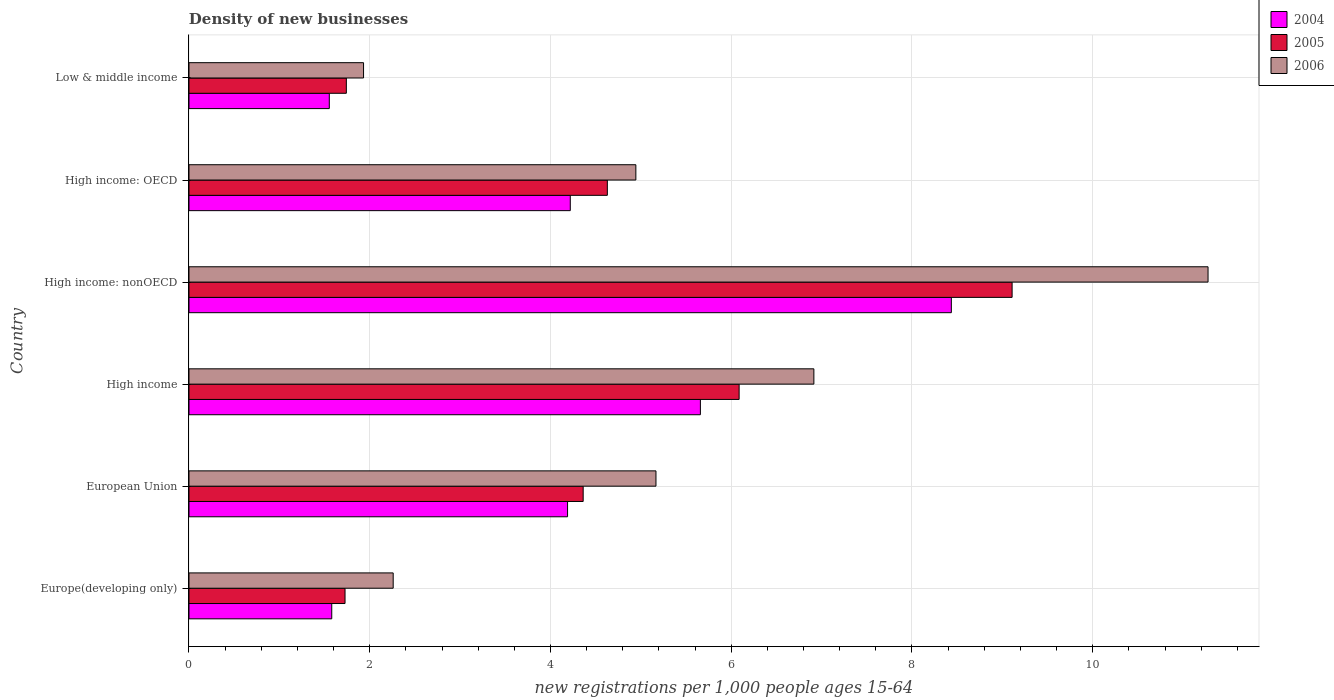How many groups of bars are there?
Keep it short and to the point. 6. Are the number of bars on each tick of the Y-axis equal?
Provide a short and direct response. Yes. How many bars are there on the 5th tick from the top?
Ensure brevity in your answer.  3. How many bars are there on the 6th tick from the bottom?
Offer a very short reply. 3. What is the label of the 5th group of bars from the top?
Your response must be concise. European Union. What is the number of new registrations in 2005 in Europe(developing only)?
Your answer should be very brief. 1.73. Across all countries, what is the maximum number of new registrations in 2006?
Give a very brief answer. 11.28. Across all countries, what is the minimum number of new registrations in 2006?
Give a very brief answer. 1.93. In which country was the number of new registrations in 2005 maximum?
Ensure brevity in your answer.  High income: nonOECD. In which country was the number of new registrations in 2004 minimum?
Provide a succinct answer. Low & middle income. What is the total number of new registrations in 2005 in the graph?
Provide a succinct answer. 27.65. What is the difference between the number of new registrations in 2005 in High income: OECD and that in High income: nonOECD?
Provide a succinct answer. -4.48. What is the difference between the number of new registrations in 2005 in Europe(developing only) and the number of new registrations in 2006 in Low & middle income?
Provide a succinct answer. -0.2. What is the average number of new registrations in 2006 per country?
Keep it short and to the point. 5.42. What is the difference between the number of new registrations in 2005 and number of new registrations in 2006 in European Union?
Offer a terse response. -0.81. In how many countries, is the number of new registrations in 2005 greater than 7.2 ?
Provide a short and direct response. 1. What is the ratio of the number of new registrations in 2005 in European Union to that in High income?
Offer a very short reply. 0.72. Is the number of new registrations in 2004 in High income: nonOECD less than that in Low & middle income?
Provide a succinct answer. No. What is the difference between the highest and the second highest number of new registrations in 2004?
Your answer should be compact. 2.78. What is the difference between the highest and the lowest number of new registrations in 2006?
Your answer should be compact. 9.34. In how many countries, is the number of new registrations in 2005 greater than the average number of new registrations in 2005 taken over all countries?
Offer a very short reply. 3. What does the 3rd bar from the top in European Union represents?
Provide a succinct answer. 2004. Is it the case that in every country, the sum of the number of new registrations in 2005 and number of new registrations in 2004 is greater than the number of new registrations in 2006?
Your response must be concise. Yes. Are all the bars in the graph horizontal?
Your response must be concise. Yes. How many countries are there in the graph?
Offer a very short reply. 6. What is the difference between two consecutive major ticks on the X-axis?
Your answer should be very brief. 2. Does the graph contain grids?
Make the answer very short. Yes. How many legend labels are there?
Ensure brevity in your answer.  3. What is the title of the graph?
Your answer should be compact. Density of new businesses. What is the label or title of the X-axis?
Provide a short and direct response. New registrations per 1,0 people ages 15-64. What is the new registrations per 1,000 people ages 15-64 in 2004 in Europe(developing only)?
Your response must be concise. 1.58. What is the new registrations per 1,000 people ages 15-64 in 2005 in Europe(developing only)?
Give a very brief answer. 1.73. What is the new registrations per 1,000 people ages 15-64 in 2006 in Europe(developing only)?
Make the answer very short. 2.26. What is the new registrations per 1,000 people ages 15-64 in 2004 in European Union?
Your response must be concise. 4.19. What is the new registrations per 1,000 people ages 15-64 in 2005 in European Union?
Ensure brevity in your answer.  4.36. What is the new registrations per 1,000 people ages 15-64 of 2006 in European Union?
Your answer should be very brief. 5.17. What is the new registrations per 1,000 people ages 15-64 of 2004 in High income?
Your response must be concise. 5.66. What is the new registrations per 1,000 people ages 15-64 of 2005 in High income?
Make the answer very short. 6.09. What is the new registrations per 1,000 people ages 15-64 in 2006 in High income?
Your answer should be very brief. 6.91. What is the new registrations per 1,000 people ages 15-64 in 2004 in High income: nonOECD?
Offer a terse response. 8.44. What is the new registrations per 1,000 people ages 15-64 of 2005 in High income: nonOECD?
Give a very brief answer. 9.11. What is the new registrations per 1,000 people ages 15-64 of 2006 in High income: nonOECD?
Offer a very short reply. 11.28. What is the new registrations per 1,000 people ages 15-64 of 2004 in High income: OECD?
Your answer should be very brief. 4.22. What is the new registrations per 1,000 people ages 15-64 of 2005 in High income: OECD?
Ensure brevity in your answer.  4.63. What is the new registrations per 1,000 people ages 15-64 in 2006 in High income: OECD?
Keep it short and to the point. 4.94. What is the new registrations per 1,000 people ages 15-64 in 2004 in Low & middle income?
Give a very brief answer. 1.55. What is the new registrations per 1,000 people ages 15-64 in 2005 in Low & middle income?
Ensure brevity in your answer.  1.74. What is the new registrations per 1,000 people ages 15-64 of 2006 in Low & middle income?
Offer a very short reply. 1.93. Across all countries, what is the maximum new registrations per 1,000 people ages 15-64 of 2004?
Provide a short and direct response. 8.44. Across all countries, what is the maximum new registrations per 1,000 people ages 15-64 of 2005?
Give a very brief answer. 9.11. Across all countries, what is the maximum new registrations per 1,000 people ages 15-64 in 2006?
Offer a terse response. 11.28. Across all countries, what is the minimum new registrations per 1,000 people ages 15-64 in 2004?
Ensure brevity in your answer.  1.55. Across all countries, what is the minimum new registrations per 1,000 people ages 15-64 of 2005?
Offer a terse response. 1.73. Across all countries, what is the minimum new registrations per 1,000 people ages 15-64 in 2006?
Your response must be concise. 1.93. What is the total new registrations per 1,000 people ages 15-64 in 2004 in the graph?
Keep it short and to the point. 25.63. What is the total new registrations per 1,000 people ages 15-64 in 2005 in the graph?
Ensure brevity in your answer.  27.65. What is the total new registrations per 1,000 people ages 15-64 in 2006 in the graph?
Provide a short and direct response. 32.49. What is the difference between the new registrations per 1,000 people ages 15-64 of 2004 in Europe(developing only) and that in European Union?
Make the answer very short. -2.61. What is the difference between the new registrations per 1,000 people ages 15-64 in 2005 in Europe(developing only) and that in European Union?
Keep it short and to the point. -2.64. What is the difference between the new registrations per 1,000 people ages 15-64 of 2006 in Europe(developing only) and that in European Union?
Your answer should be compact. -2.91. What is the difference between the new registrations per 1,000 people ages 15-64 of 2004 in Europe(developing only) and that in High income?
Provide a succinct answer. -4.08. What is the difference between the new registrations per 1,000 people ages 15-64 in 2005 in Europe(developing only) and that in High income?
Your response must be concise. -4.36. What is the difference between the new registrations per 1,000 people ages 15-64 in 2006 in Europe(developing only) and that in High income?
Provide a short and direct response. -4.66. What is the difference between the new registrations per 1,000 people ages 15-64 in 2004 in Europe(developing only) and that in High income: nonOECD?
Give a very brief answer. -6.86. What is the difference between the new registrations per 1,000 people ages 15-64 in 2005 in Europe(developing only) and that in High income: nonOECD?
Provide a succinct answer. -7.38. What is the difference between the new registrations per 1,000 people ages 15-64 of 2006 in Europe(developing only) and that in High income: nonOECD?
Your response must be concise. -9.02. What is the difference between the new registrations per 1,000 people ages 15-64 in 2004 in Europe(developing only) and that in High income: OECD?
Your answer should be compact. -2.64. What is the difference between the new registrations per 1,000 people ages 15-64 in 2005 in Europe(developing only) and that in High income: OECD?
Your response must be concise. -2.9. What is the difference between the new registrations per 1,000 people ages 15-64 in 2006 in Europe(developing only) and that in High income: OECD?
Your response must be concise. -2.69. What is the difference between the new registrations per 1,000 people ages 15-64 in 2004 in Europe(developing only) and that in Low & middle income?
Offer a very short reply. 0.03. What is the difference between the new registrations per 1,000 people ages 15-64 of 2005 in Europe(developing only) and that in Low & middle income?
Ensure brevity in your answer.  -0.01. What is the difference between the new registrations per 1,000 people ages 15-64 of 2006 in Europe(developing only) and that in Low & middle income?
Your answer should be very brief. 0.33. What is the difference between the new registrations per 1,000 people ages 15-64 of 2004 in European Union and that in High income?
Ensure brevity in your answer.  -1.47. What is the difference between the new registrations per 1,000 people ages 15-64 in 2005 in European Union and that in High income?
Your response must be concise. -1.73. What is the difference between the new registrations per 1,000 people ages 15-64 in 2006 in European Union and that in High income?
Keep it short and to the point. -1.75. What is the difference between the new registrations per 1,000 people ages 15-64 in 2004 in European Union and that in High income: nonOECD?
Offer a very short reply. -4.25. What is the difference between the new registrations per 1,000 people ages 15-64 in 2005 in European Union and that in High income: nonOECD?
Your response must be concise. -4.75. What is the difference between the new registrations per 1,000 people ages 15-64 of 2006 in European Union and that in High income: nonOECD?
Make the answer very short. -6.11. What is the difference between the new registrations per 1,000 people ages 15-64 in 2004 in European Union and that in High income: OECD?
Keep it short and to the point. -0.03. What is the difference between the new registrations per 1,000 people ages 15-64 of 2005 in European Union and that in High income: OECD?
Make the answer very short. -0.27. What is the difference between the new registrations per 1,000 people ages 15-64 of 2006 in European Union and that in High income: OECD?
Provide a short and direct response. 0.22. What is the difference between the new registrations per 1,000 people ages 15-64 of 2004 in European Union and that in Low & middle income?
Your answer should be very brief. 2.64. What is the difference between the new registrations per 1,000 people ages 15-64 in 2005 in European Union and that in Low & middle income?
Keep it short and to the point. 2.62. What is the difference between the new registrations per 1,000 people ages 15-64 in 2006 in European Union and that in Low & middle income?
Keep it short and to the point. 3.24. What is the difference between the new registrations per 1,000 people ages 15-64 of 2004 in High income and that in High income: nonOECD?
Your answer should be compact. -2.78. What is the difference between the new registrations per 1,000 people ages 15-64 of 2005 in High income and that in High income: nonOECD?
Provide a succinct answer. -3.02. What is the difference between the new registrations per 1,000 people ages 15-64 in 2006 in High income and that in High income: nonOECD?
Keep it short and to the point. -4.36. What is the difference between the new registrations per 1,000 people ages 15-64 in 2004 in High income and that in High income: OECD?
Provide a succinct answer. 1.44. What is the difference between the new registrations per 1,000 people ages 15-64 in 2005 in High income and that in High income: OECD?
Keep it short and to the point. 1.46. What is the difference between the new registrations per 1,000 people ages 15-64 in 2006 in High income and that in High income: OECD?
Provide a succinct answer. 1.97. What is the difference between the new registrations per 1,000 people ages 15-64 of 2004 in High income and that in Low & middle income?
Your answer should be very brief. 4.11. What is the difference between the new registrations per 1,000 people ages 15-64 in 2005 in High income and that in Low & middle income?
Your response must be concise. 4.35. What is the difference between the new registrations per 1,000 people ages 15-64 in 2006 in High income and that in Low & middle income?
Keep it short and to the point. 4.98. What is the difference between the new registrations per 1,000 people ages 15-64 of 2004 in High income: nonOECD and that in High income: OECD?
Provide a succinct answer. 4.22. What is the difference between the new registrations per 1,000 people ages 15-64 of 2005 in High income: nonOECD and that in High income: OECD?
Your answer should be compact. 4.48. What is the difference between the new registrations per 1,000 people ages 15-64 in 2006 in High income: nonOECD and that in High income: OECD?
Your response must be concise. 6.33. What is the difference between the new registrations per 1,000 people ages 15-64 of 2004 in High income: nonOECD and that in Low & middle income?
Offer a terse response. 6.88. What is the difference between the new registrations per 1,000 people ages 15-64 in 2005 in High income: nonOECD and that in Low & middle income?
Offer a terse response. 7.37. What is the difference between the new registrations per 1,000 people ages 15-64 in 2006 in High income: nonOECD and that in Low & middle income?
Ensure brevity in your answer.  9.34. What is the difference between the new registrations per 1,000 people ages 15-64 of 2004 in High income: OECD and that in Low & middle income?
Your response must be concise. 2.67. What is the difference between the new registrations per 1,000 people ages 15-64 of 2005 in High income: OECD and that in Low & middle income?
Keep it short and to the point. 2.89. What is the difference between the new registrations per 1,000 people ages 15-64 in 2006 in High income: OECD and that in Low & middle income?
Your answer should be compact. 3.01. What is the difference between the new registrations per 1,000 people ages 15-64 in 2004 in Europe(developing only) and the new registrations per 1,000 people ages 15-64 in 2005 in European Union?
Your response must be concise. -2.78. What is the difference between the new registrations per 1,000 people ages 15-64 of 2004 in Europe(developing only) and the new registrations per 1,000 people ages 15-64 of 2006 in European Union?
Make the answer very short. -3.59. What is the difference between the new registrations per 1,000 people ages 15-64 in 2005 in Europe(developing only) and the new registrations per 1,000 people ages 15-64 in 2006 in European Union?
Provide a succinct answer. -3.44. What is the difference between the new registrations per 1,000 people ages 15-64 of 2004 in Europe(developing only) and the new registrations per 1,000 people ages 15-64 of 2005 in High income?
Offer a terse response. -4.51. What is the difference between the new registrations per 1,000 people ages 15-64 of 2004 in Europe(developing only) and the new registrations per 1,000 people ages 15-64 of 2006 in High income?
Offer a terse response. -5.33. What is the difference between the new registrations per 1,000 people ages 15-64 of 2005 in Europe(developing only) and the new registrations per 1,000 people ages 15-64 of 2006 in High income?
Your answer should be compact. -5.19. What is the difference between the new registrations per 1,000 people ages 15-64 in 2004 in Europe(developing only) and the new registrations per 1,000 people ages 15-64 in 2005 in High income: nonOECD?
Keep it short and to the point. -7.53. What is the difference between the new registrations per 1,000 people ages 15-64 of 2004 in Europe(developing only) and the new registrations per 1,000 people ages 15-64 of 2006 in High income: nonOECD?
Your answer should be very brief. -9.7. What is the difference between the new registrations per 1,000 people ages 15-64 of 2005 in Europe(developing only) and the new registrations per 1,000 people ages 15-64 of 2006 in High income: nonOECD?
Your answer should be compact. -9.55. What is the difference between the new registrations per 1,000 people ages 15-64 of 2004 in Europe(developing only) and the new registrations per 1,000 people ages 15-64 of 2005 in High income: OECD?
Keep it short and to the point. -3.05. What is the difference between the new registrations per 1,000 people ages 15-64 in 2004 in Europe(developing only) and the new registrations per 1,000 people ages 15-64 in 2006 in High income: OECD?
Provide a succinct answer. -3.37. What is the difference between the new registrations per 1,000 people ages 15-64 of 2005 in Europe(developing only) and the new registrations per 1,000 people ages 15-64 of 2006 in High income: OECD?
Offer a very short reply. -3.22. What is the difference between the new registrations per 1,000 people ages 15-64 in 2004 in Europe(developing only) and the new registrations per 1,000 people ages 15-64 in 2005 in Low & middle income?
Provide a succinct answer. -0.16. What is the difference between the new registrations per 1,000 people ages 15-64 of 2004 in Europe(developing only) and the new registrations per 1,000 people ages 15-64 of 2006 in Low & middle income?
Ensure brevity in your answer.  -0.35. What is the difference between the new registrations per 1,000 people ages 15-64 in 2005 in Europe(developing only) and the new registrations per 1,000 people ages 15-64 in 2006 in Low & middle income?
Give a very brief answer. -0.2. What is the difference between the new registrations per 1,000 people ages 15-64 in 2004 in European Union and the new registrations per 1,000 people ages 15-64 in 2005 in High income?
Your response must be concise. -1.9. What is the difference between the new registrations per 1,000 people ages 15-64 in 2004 in European Union and the new registrations per 1,000 people ages 15-64 in 2006 in High income?
Your answer should be very brief. -2.73. What is the difference between the new registrations per 1,000 people ages 15-64 of 2005 in European Union and the new registrations per 1,000 people ages 15-64 of 2006 in High income?
Your answer should be compact. -2.55. What is the difference between the new registrations per 1,000 people ages 15-64 in 2004 in European Union and the new registrations per 1,000 people ages 15-64 in 2005 in High income: nonOECD?
Your answer should be compact. -4.92. What is the difference between the new registrations per 1,000 people ages 15-64 of 2004 in European Union and the new registrations per 1,000 people ages 15-64 of 2006 in High income: nonOECD?
Give a very brief answer. -7.09. What is the difference between the new registrations per 1,000 people ages 15-64 of 2005 in European Union and the new registrations per 1,000 people ages 15-64 of 2006 in High income: nonOECD?
Your answer should be compact. -6.91. What is the difference between the new registrations per 1,000 people ages 15-64 in 2004 in European Union and the new registrations per 1,000 people ages 15-64 in 2005 in High income: OECD?
Provide a succinct answer. -0.44. What is the difference between the new registrations per 1,000 people ages 15-64 of 2004 in European Union and the new registrations per 1,000 people ages 15-64 of 2006 in High income: OECD?
Your answer should be very brief. -0.76. What is the difference between the new registrations per 1,000 people ages 15-64 of 2005 in European Union and the new registrations per 1,000 people ages 15-64 of 2006 in High income: OECD?
Provide a succinct answer. -0.58. What is the difference between the new registrations per 1,000 people ages 15-64 in 2004 in European Union and the new registrations per 1,000 people ages 15-64 in 2005 in Low & middle income?
Make the answer very short. 2.45. What is the difference between the new registrations per 1,000 people ages 15-64 of 2004 in European Union and the new registrations per 1,000 people ages 15-64 of 2006 in Low & middle income?
Your response must be concise. 2.26. What is the difference between the new registrations per 1,000 people ages 15-64 of 2005 in European Union and the new registrations per 1,000 people ages 15-64 of 2006 in Low & middle income?
Your answer should be very brief. 2.43. What is the difference between the new registrations per 1,000 people ages 15-64 in 2004 in High income and the new registrations per 1,000 people ages 15-64 in 2005 in High income: nonOECD?
Provide a succinct answer. -3.45. What is the difference between the new registrations per 1,000 people ages 15-64 of 2004 in High income and the new registrations per 1,000 people ages 15-64 of 2006 in High income: nonOECD?
Provide a succinct answer. -5.62. What is the difference between the new registrations per 1,000 people ages 15-64 in 2005 in High income and the new registrations per 1,000 people ages 15-64 in 2006 in High income: nonOECD?
Give a very brief answer. -5.19. What is the difference between the new registrations per 1,000 people ages 15-64 in 2004 in High income and the new registrations per 1,000 people ages 15-64 in 2005 in High income: OECD?
Your answer should be very brief. 1.03. What is the difference between the new registrations per 1,000 people ages 15-64 of 2004 in High income and the new registrations per 1,000 people ages 15-64 of 2006 in High income: OECD?
Your answer should be compact. 0.71. What is the difference between the new registrations per 1,000 people ages 15-64 in 2005 in High income and the new registrations per 1,000 people ages 15-64 in 2006 in High income: OECD?
Your response must be concise. 1.14. What is the difference between the new registrations per 1,000 people ages 15-64 in 2004 in High income and the new registrations per 1,000 people ages 15-64 in 2005 in Low & middle income?
Offer a very short reply. 3.92. What is the difference between the new registrations per 1,000 people ages 15-64 of 2004 in High income and the new registrations per 1,000 people ages 15-64 of 2006 in Low & middle income?
Give a very brief answer. 3.73. What is the difference between the new registrations per 1,000 people ages 15-64 in 2005 in High income and the new registrations per 1,000 people ages 15-64 in 2006 in Low & middle income?
Make the answer very short. 4.16. What is the difference between the new registrations per 1,000 people ages 15-64 of 2004 in High income: nonOECD and the new registrations per 1,000 people ages 15-64 of 2005 in High income: OECD?
Your answer should be very brief. 3.81. What is the difference between the new registrations per 1,000 people ages 15-64 in 2004 in High income: nonOECD and the new registrations per 1,000 people ages 15-64 in 2006 in High income: OECD?
Make the answer very short. 3.49. What is the difference between the new registrations per 1,000 people ages 15-64 in 2005 in High income: nonOECD and the new registrations per 1,000 people ages 15-64 in 2006 in High income: OECD?
Your answer should be very brief. 4.16. What is the difference between the new registrations per 1,000 people ages 15-64 of 2004 in High income: nonOECD and the new registrations per 1,000 people ages 15-64 of 2005 in Low & middle income?
Your response must be concise. 6.69. What is the difference between the new registrations per 1,000 people ages 15-64 in 2004 in High income: nonOECD and the new registrations per 1,000 people ages 15-64 in 2006 in Low & middle income?
Give a very brief answer. 6.5. What is the difference between the new registrations per 1,000 people ages 15-64 of 2005 in High income: nonOECD and the new registrations per 1,000 people ages 15-64 of 2006 in Low & middle income?
Provide a short and direct response. 7.18. What is the difference between the new registrations per 1,000 people ages 15-64 of 2004 in High income: OECD and the new registrations per 1,000 people ages 15-64 of 2005 in Low & middle income?
Give a very brief answer. 2.48. What is the difference between the new registrations per 1,000 people ages 15-64 in 2004 in High income: OECD and the new registrations per 1,000 people ages 15-64 in 2006 in Low & middle income?
Provide a succinct answer. 2.29. What is the difference between the new registrations per 1,000 people ages 15-64 in 2005 in High income: OECD and the new registrations per 1,000 people ages 15-64 in 2006 in Low & middle income?
Offer a terse response. 2.7. What is the average new registrations per 1,000 people ages 15-64 of 2004 per country?
Offer a very short reply. 4.27. What is the average new registrations per 1,000 people ages 15-64 in 2005 per country?
Provide a short and direct response. 4.61. What is the average new registrations per 1,000 people ages 15-64 of 2006 per country?
Make the answer very short. 5.42. What is the difference between the new registrations per 1,000 people ages 15-64 of 2004 and new registrations per 1,000 people ages 15-64 of 2005 in Europe(developing only)?
Offer a very short reply. -0.15. What is the difference between the new registrations per 1,000 people ages 15-64 of 2004 and new registrations per 1,000 people ages 15-64 of 2006 in Europe(developing only)?
Make the answer very short. -0.68. What is the difference between the new registrations per 1,000 people ages 15-64 in 2005 and new registrations per 1,000 people ages 15-64 in 2006 in Europe(developing only)?
Your answer should be compact. -0.53. What is the difference between the new registrations per 1,000 people ages 15-64 of 2004 and new registrations per 1,000 people ages 15-64 of 2005 in European Union?
Make the answer very short. -0.17. What is the difference between the new registrations per 1,000 people ages 15-64 in 2004 and new registrations per 1,000 people ages 15-64 in 2006 in European Union?
Your response must be concise. -0.98. What is the difference between the new registrations per 1,000 people ages 15-64 of 2005 and new registrations per 1,000 people ages 15-64 of 2006 in European Union?
Your answer should be compact. -0.81. What is the difference between the new registrations per 1,000 people ages 15-64 of 2004 and new registrations per 1,000 people ages 15-64 of 2005 in High income?
Provide a succinct answer. -0.43. What is the difference between the new registrations per 1,000 people ages 15-64 in 2004 and new registrations per 1,000 people ages 15-64 in 2006 in High income?
Your answer should be very brief. -1.26. What is the difference between the new registrations per 1,000 people ages 15-64 in 2005 and new registrations per 1,000 people ages 15-64 in 2006 in High income?
Offer a terse response. -0.83. What is the difference between the new registrations per 1,000 people ages 15-64 of 2004 and new registrations per 1,000 people ages 15-64 of 2005 in High income: nonOECD?
Your response must be concise. -0.67. What is the difference between the new registrations per 1,000 people ages 15-64 of 2004 and new registrations per 1,000 people ages 15-64 of 2006 in High income: nonOECD?
Ensure brevity in your answer.  -2.84. What is the difference between the new registrations per 1,000 people ages 15-64 of 2005 and new registrations per 1,000 people ages 15-64 of 2006 in High income: nonOECD?
Offer a very short reply. -2.17. What is the difference between the new registrations per 1,000 people ages 15-64 of 2004 and new registrations per 1,000 people ages 15-64 of 2005 in High income: OECD?
Provide a succinct answer. -0.41. What is the difference between the new registrations per 1,000 people ages 15-64 of 2004 and new registrations per 1,000 people ages 15-64 of 2006 in High income: OECD?
Your answer should be compact. -0.73. What is the difference between the new registrations per 1,000 people ages 15-64 of 2005 and new registrations per 1,000 people ages 15-64 of 2006 in High income: OECD?
Offer a terse response. -0.32. What is the difference between the new registrations per 1,000 people ages 15-64 of 2004 and new registrations per 1,000 people ages 15-64 of 2005 in Low & middle income?
Ensure brevity in your answer.  -0.19. What is the difference between the new registrations per 1,000 people ages 15-64 of 2004 and new registrations per 1,000 people ages 15-64 of 2006 in Low & middle income?
Provide a succinct answer. -0.38. What is the difference between the new registrations per 1,000 people ages 15-64 in 2005 and new registrations per 1,000 people ages 15-64 in 2006 in Low & middle income?
Your answer should be very brief. -0.19. What is the ratio of the new registrations per 1,000 people ages 15-64 in 2004 in Europe(developing only) to that in European Union?
Your answer should be very brief. 0.38. What is the ratio of the new registrations per 1,000 people ages 15-64 in 2005 in Europe(developing only) to that in European Union?
Provide a short and direct response. 0.4. What is the ratio of the new registrations per 1,000 people ages 15-64 in 2006 in Europe(developing only) to that in European Union?
Give a very brief answer. 0.44. What is the ratio of the new registrations per 1,000 people ages 15-64 in 2004 in Europe(developing only) to that in High income?
Your response must be concise. 0.28. What is the ratio of the new registrations per 1,000 people ages 15-64 of 2005 in Europe(developing only) to that in High income?
Your answer should be very brief. 0.28. What is the ratio of the new registrations per 1,000 people ages 15-64 of 2006 in Europe(developing only) to that in High income?
Provide a short and direct response. 0.33. What is the ratio of the new registrations per 1,000 people ages 15-64 in 2004 in Europe(developing only) to that in High income: nonOECD?
Your answer should be very brief. 0.19. What is the ratio of the new registrations per 1,000 people ages 15-64 of 2005 in Europe(developing only) to that in High income: nonOECD?
Make the answer very short. 0.19. What is the ratio of the new registrations per 1,000 people ages 15-64 of 2006 in Europe(developing only) to that in High income: nonOECD?
Provide a short and direct response. 0.2. What is the ratio of the new registrations per 1,000 people ages 15-64 in 2004 in Europe(developing only) to that in High income: OECD?
Offer a very short reply. 0.37. What is the ratio of the new registrations per 1,000 people ages 15-64 in 2005 in Europe(developing only) to that in High income: OECD?
Give a very brief answer. 0.37. What is the ratio of the new registrations per 1,000 people ages 15-64 in 2006 in Europe(developing only) to that in High income: OECD?
Provide a succinct answer. 0.46. What is the ratio of the new registrations per 1,000 people ages 15-64 in 2004 in Europe(developing only) to that in Low & middle income?
Your answer should be compact. 1.02. What is the ratio of the new registrations per 1,000 people ages 15-64 of 2005 in Europe(developing only) to that in Low & middle income?
Your answer should be very brief. 0.99. What is the ratio of the new registrations per 1,000 people ages 15-64 in 2006 in Europe(developing only) to that in Low & middle income?
Give a very brief answer. 1.17. What is the ratio of the new registrations per 1,000 people ages 15-64 of 2004 in European Union to that in High income?
Your answer should be compact. 0.74. What is the ratio of the new registrations per 1,000 people ages 15-64 in 2005 in European Union to that in High income?
Provide a short and direct response. 0.72. What is the ratio of the new registrations per 1,000 people ages 15-64 in 2006 in European Union to that in High income?
Offer a very short reply. 0.75. What is the ratio of the new registrations per 1,000 people ages 15-64 in 2004 in European Union to that in High income: nonOECD?
Your response must be concise. 0.5. What is the ratio of the new registrations per 1,000 people ages 15-64 of 2005 in European Union to that in High income: nonOECD?
Give a very brief answer. 0.48. What is the ratio of the new registrations per 1,000 people ages 15-64 in 2006 in European Union to that in High income: nonOECD?
Your response must be concise. 0.46. What is the ratio of the new registrations per 1,000 people ages 15-64 in 2004 in European Union to that in High income: OECD?
Offer a very short reply. 0.99. What is the ratio of the new registrations per 1,000 people ages 15-64 in 2005 in European Union to that in High income: OECD?
Provide a succinct answer. 0.94. What is the ratio of the new registrations per 1,000 people ages 15-64 in 2006 in European Union to that in High income: OECD?
Ensure brevity in your answer.  1.04. What is the ratio of the new registrations per 1,000 people ages 15-64 of 2004 in European Union to that in Low & middle income?
Your answer should be very brief. 2.7. What is the ratio of the new registrations per 1,000 people ages 15-64 of 2005 in European Union to that in Low & middle income?
Keep it short and to the point. 2.51. What is the ratio of the new registrations per 1,000 people ages 15-64 in 2006 in European Union to that in Low & middle income?
Offer a terse response. 2.68. What is the ratio of the new registrations per 1,000 people ages 15-64 in 2004 in High income to that in High income: nonOECD?
Provide a succinct answer. 0.67. What is the ratio of the new registrations per 1,000 people ages 15-64 of 2005 in High income to that in High income: nonOECD?
Provide a short and direct response. 0.67. What is the ratio of the new registrations per 1,000 people ages 15-64 in 2006 in High income to that in High income: nonOECD?
Provide a short and direct response. 0.61. What is the ratio of the new registrations per 1,000 people ages 15-64 in 2004 in High income to that in High income: OECD?
Your answer should be compact. 1.34. What is the ratio of the new registrations per 1,000 people ages 15-64 of 2005 in High income to that in High income: OECD?
Give a very brief answer. 1.31. What is the ratio of the new registrations per 1,000 people ages 15-64 in 2006 in High income to that in High income: OECD?
Your answer should be compact. 1.4. What is the ratio of the new registrations per 1,000 people ages 15-64 of 2004 in High income to that in Low & middle income?
Provide a succinct answer. 3.64. What is the ratio of the new registrations per 1,000 people ages 15-64 of 2005 in High income to that in Low & middle income?
Provide a short and direct response. 3.5. What is the ratio of the new registrations per 1,000 people ages 15-64 of 2006 in High income to that in Low & middle income?
Give a very brief answer. 3.58. What is the ratio of the new registrations per 1,000 people ages 15-64 in 2004 in High income: nonOECD to that in High income: OECD?
Your answer should be compact. 2. What is the ratio of the new registrations per 1,000 people ages 15-64 of 2005 in High income: nonOECD to that in High income: OECD?
Offer a very short reply. 1.97. What is the ratio of the new registrations per 1,000 people ages 15-64 of 2006 in High income: nonOECD to that in High income: OECD?
Keep it short and to the point. 2.28. What is the ratio of the new registrations per 1,000 people ages 15-64 in 2004 in High income: nonOECD to that in Low & middle income?
Make the answer very short. 5.43. What is the ratio of the new registrations per 1,000 people ages 15-64 in 2005 in High income: nonOECD to that in Low & middle income?
Your answer should be compact. 5.23. What is the ratio of the new registrations per 1,000 people ages 15-64 of 2006 in High income: nonOECD to that in Low & middle income?
Ensure brevity in your answer.  5.84. What is the ratio of the new registrations per 1,000 people ages 15-64 in 2004 in High income: OECD to that in Low & middle income?
Make the answer very short. 2.72. What is the ratio of the new registrations per 1,000 people ages 15-64 in 2005 in High income: OECD to that in Low & middle income?
Ensure brevity in your answer.  2.66. What is the ratio of the new registrations per 1,000 people ages 15-64 in 2006 in High income: OECD to that in Low & middle income?
Offer a very short reply. 2.56. What is the difference between the highest and the second highest new registrations per 1,000 people ages 15-64 of 2004?
Your answer should be compact. 2.78. What is the difference between the highest and the second highest new registrations per 1,000 people ages 15-64 in 2005?
Keep it short and to the point. 3.02. What is the difference between the highest and the second highest new registrations per 1,000 people ages 15-64 in 2006?
Keep it short and to the point. 4.36. What is the difference between the highest and the lowest new registrations per 1,000 people ages 15-64 of 2004?
Make the answer very short. 6.88. What is the difference between the highest and the lowest new registrations per 1,000 people ages 15-64 of 2005?
Offer a terse response. 7.38. What is the difference between the highest and the lowest new registrations per 1,000 people ages 15-64 in 2006?
Provide a short and direct response. 9.34. 